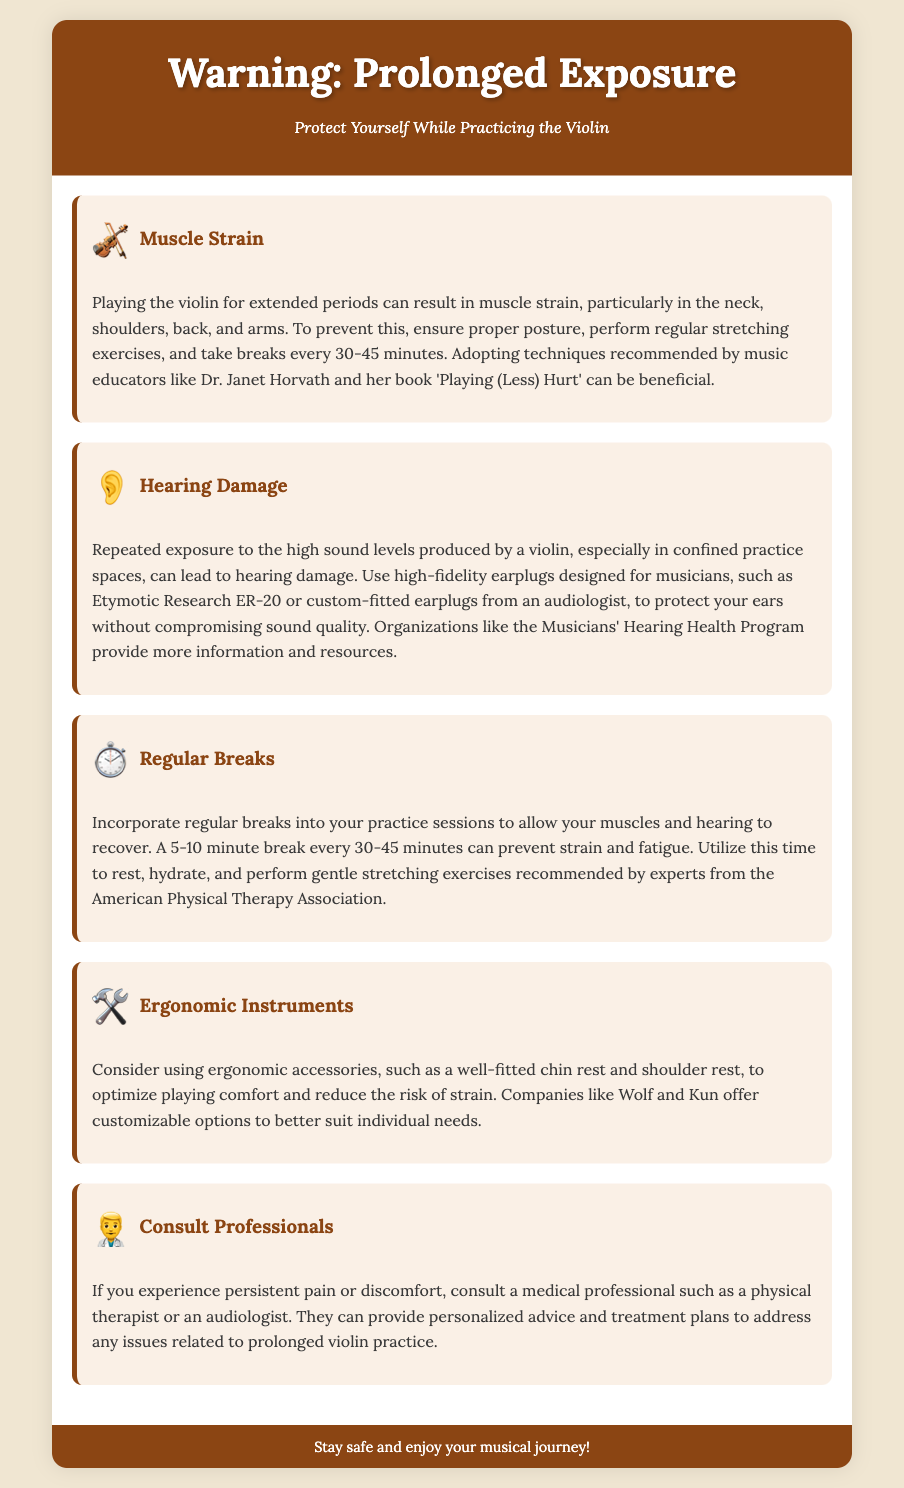What can result from prolonged violin practice? The document states that prolonged practice can result in muscle strain.
Answer: Muscle strain What should you use to protect your hearing while practicing? The document suggests using high-fidelity earplugs designed for musicians.
Answer: Earplugs How often should you take breaks during practice? It is recommended to take breaks every 30-45 minutes.
Answer: 30-45 minutes What type of accessories can help reduce strain while playing the violin? The document mentions ergonomic accessories like a well-fitted chin rest and shoulder rest.
Answer: Ergonomic accessories Who can you consult if you experience persistent pain? A medical professional such as a physical therapist or an audiologist.
Answer: Medical professional 